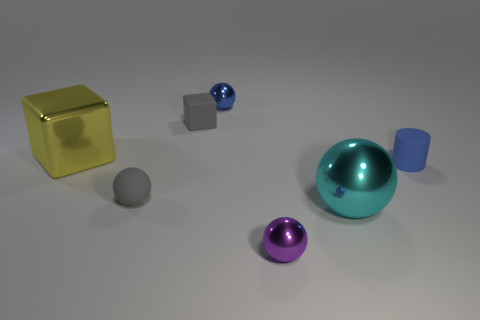Add 1 purple rubber objects. How many objects exist? 8 Subtract all cubes. How many objects are left? 5 Subtract 0 purple cylinders. How many objects are left? 7 Subtract all big cyan matte blocks. Subtract all small purple balls. How many objects are left? 6 Add 7 tiny gray rubber spheres. How many tiny gray rubber spheres are left? 8 Add 5 small blue rubber cylinders. How many small blue rubber cylinders exist? 6 